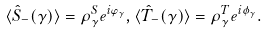Convert formula to latex. <formula><loc_0><loc_0><loc_500><loc_500>\langle \hat { S } _ { - } ( \gamma ) \rangle = \rho ^ { S } _ { \gamma } e ^ { i \varphi _ { \gamma } } , \langle \hat { T } _ { - } ( \gamma ) \rangle = \rho ^ { T } _ { \gamma } e ^ { i \phi _ { \gamma } } .</formula> 